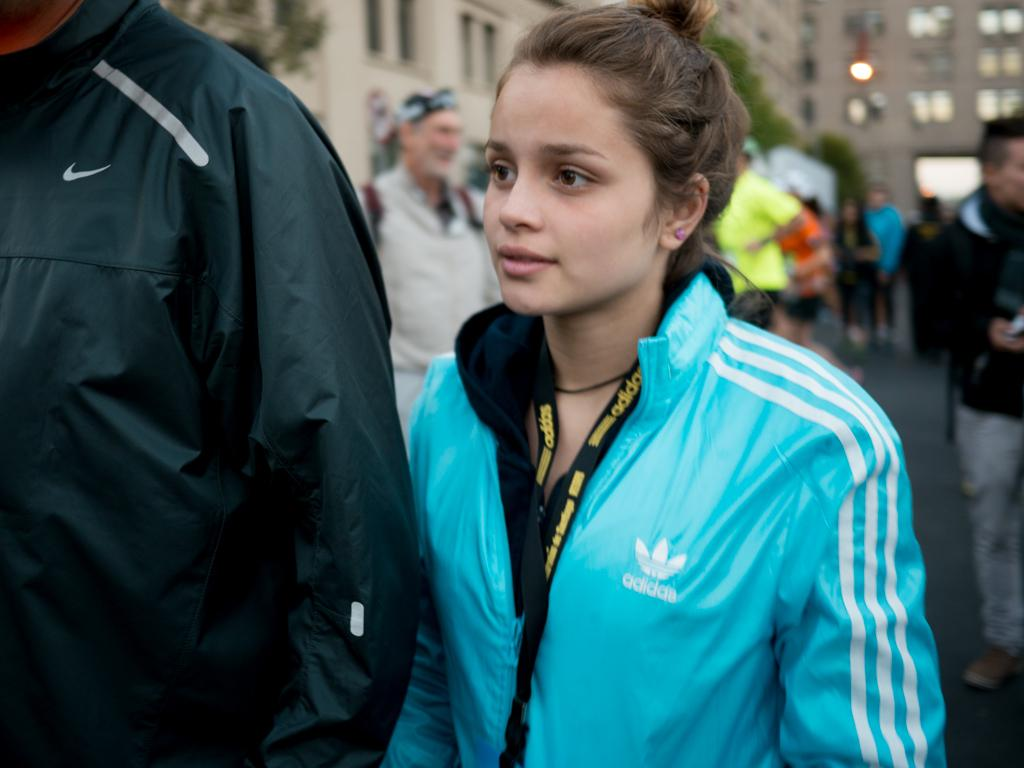What are the people in the image doing? The persons in the image are standing on the road. What can be seen in the background of the image? Buildings and trees are visible at the top of the image. What type of straw is being used for the operation in the image? There is no straw or operation present in the image. 